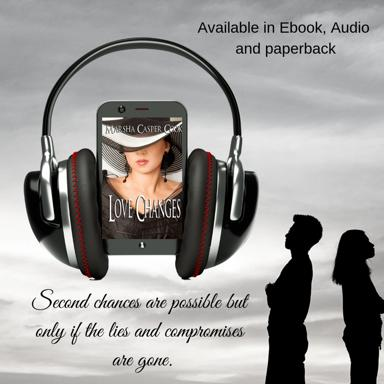What is the main idea expressed about second chances in the text? The main idea depicted in the image, concerning second chances, is quite poignant. It clearly conveys that true second chances in relationships hinge on the elimination of falsehoods and compromises, underlining the necessity for honesty and integrity for genuine renewal and growth. 